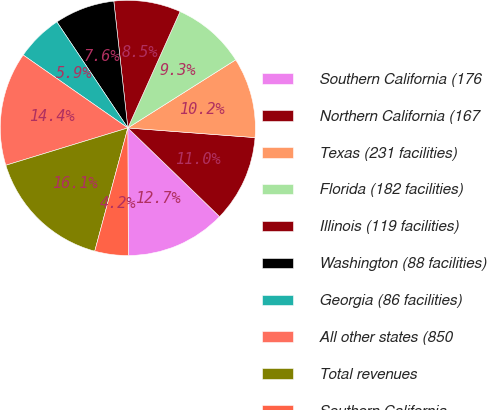<chart> <loc_0><loc_0><loc_500><loc_500><pie_chart><fcel>Southern California (176<fcel>Northern California (167<fcel>Texas (231 facilities)<fcel>Florida (182 facilities)<fcel>Illinois (119 facilities)<fcel>Washington (88 facilities)<fcel>Georgia (86 facilities)<fcel>All other states (850<fcel>Total revenues<fcel>Southern California<nl><fcel>12.71%<fcel>11.02%<fcel>10.17%<fcel>9.32%<fcel>8.47%<fcel>7.63%<fcel>5.93%<fcel>14.41%<fcel>16.1%<fcel>4.24%<nl></chart> 